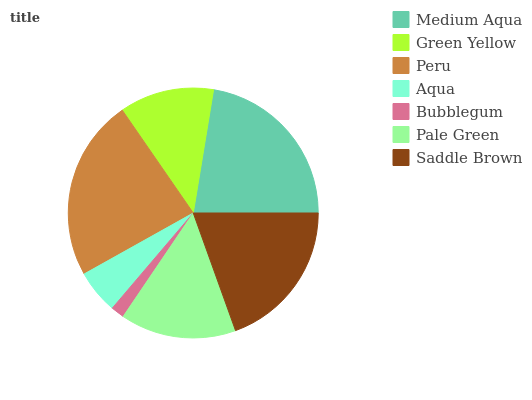Is Bubblegum the minimum?
Answer yes or no. Yes. Is Peru the maximum?
Answer yes or no. Yes. Is Green Yellow the minimum?
Answer yes or no. No. Is Green Yellow the maximum?
Answer yes or no. No. Is Medium Aqua greater than Green Yellow?
Answer yes or no. Yes. Is Green Yellow less than Medium Aqua?
Answer yes or no. Yes. Is Green Yellow greater than Medium Aqua?
Answer yes or no. No. Is Medium Aqua less than Green Yellow?
Answer yes or no. No. Is Pale Green the high median?
Answer yes or no. Yes. Is Pale Green the low median?
Answer yes or no. Yes. Is Bubblegum the high median?
Answer yes or no. No. Is Bubblegum the low median?
Answer yes or no. No. 